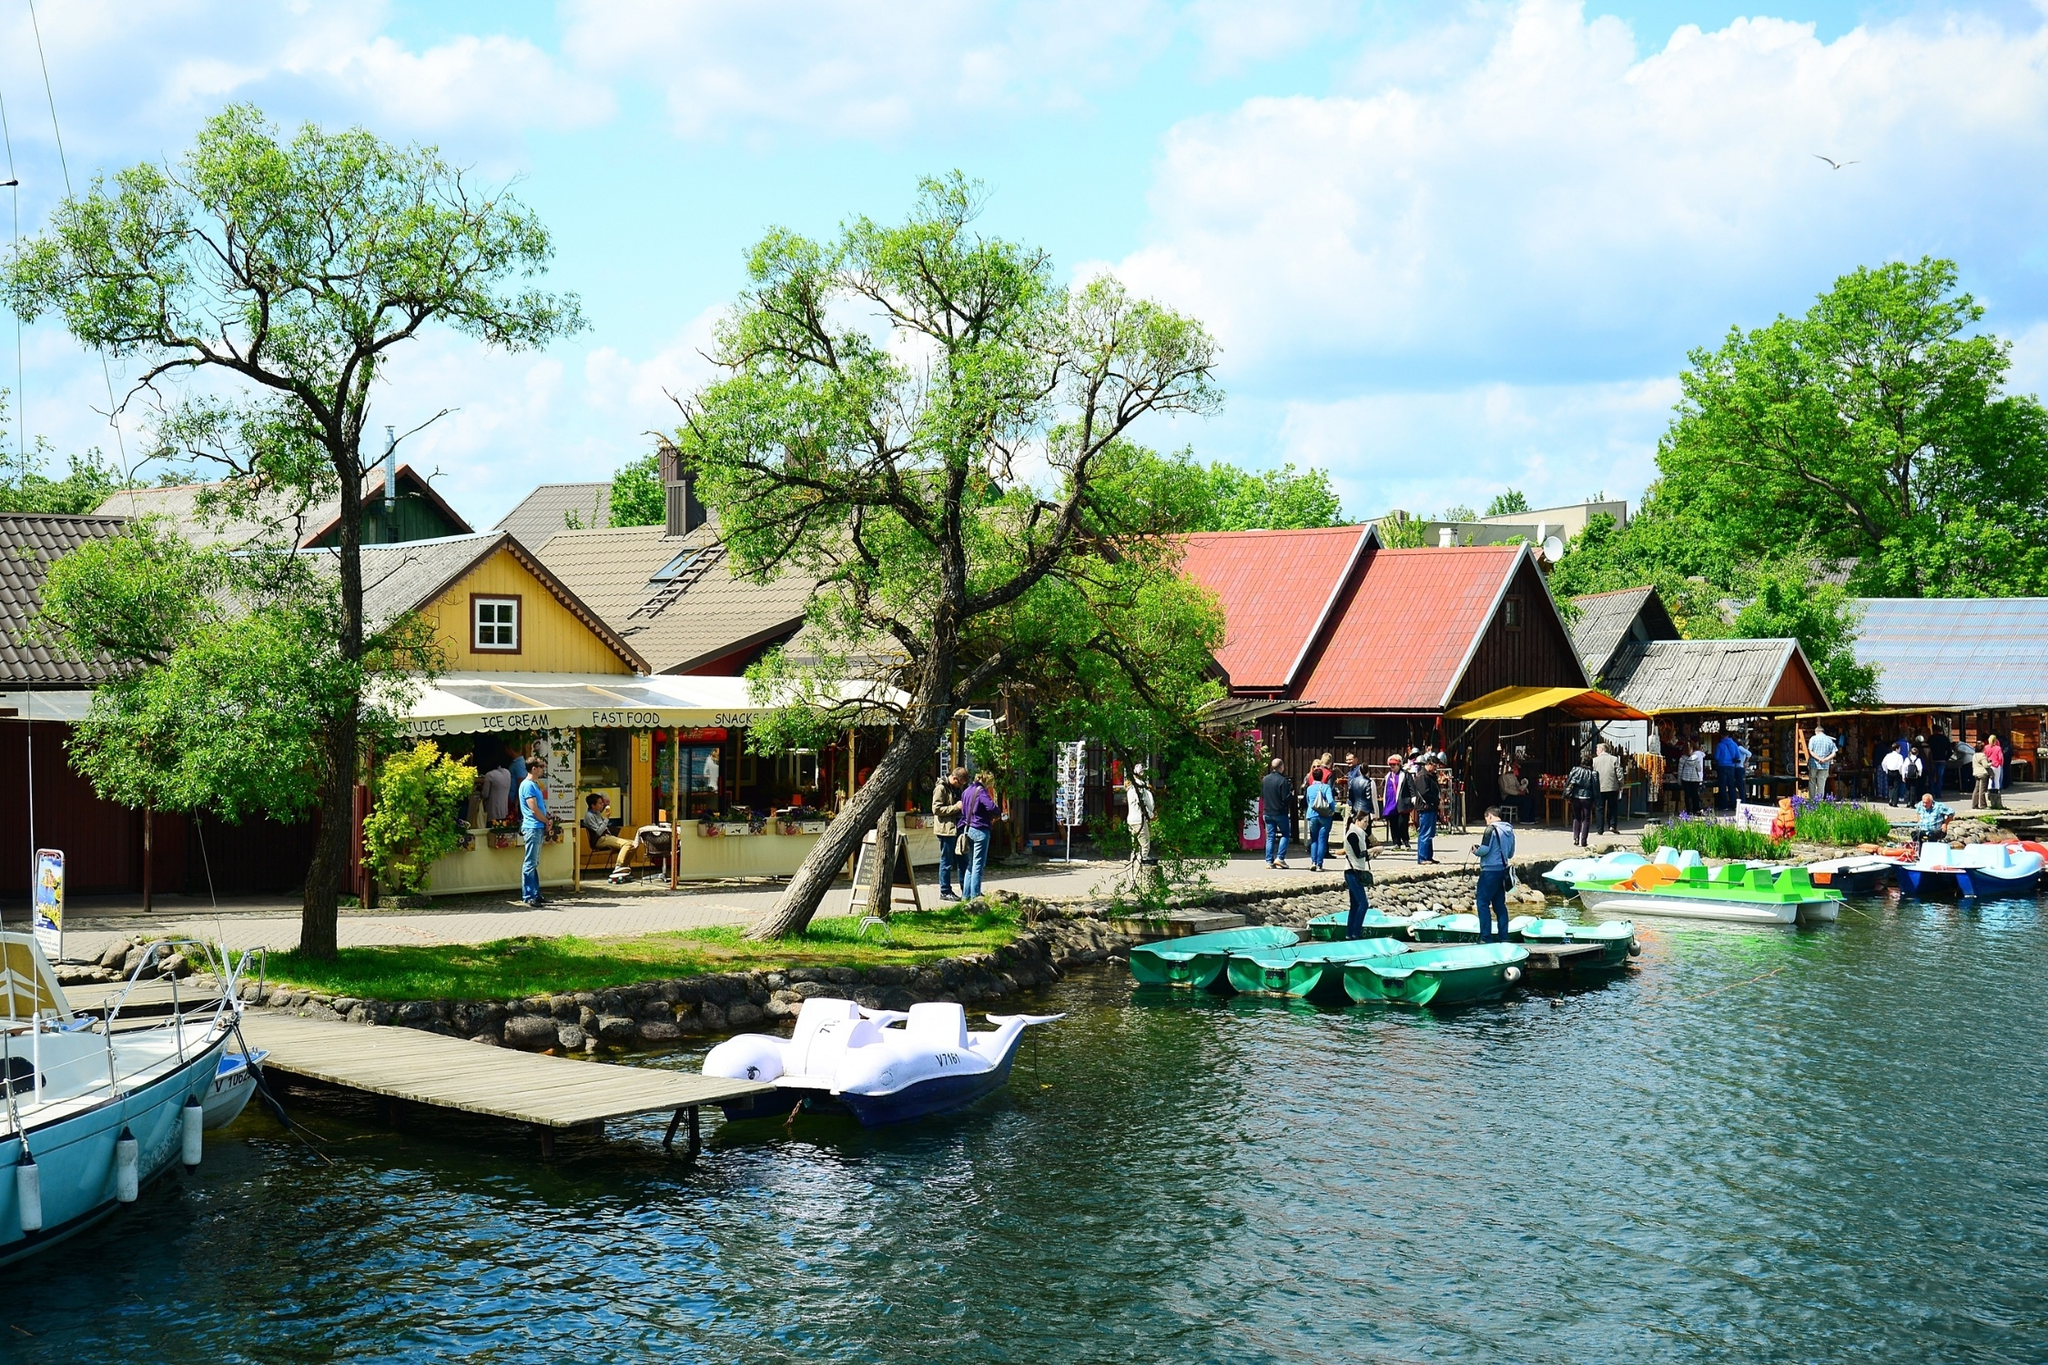Imagine this village is visited by a group of aliens. Describe their interaction with the villagers. When a group of curious and friendly aliens visited the village by the lake, the scene was nothing short of extraordinary. Their spaceship, a sleek and luminous craft, landed gently on the lake, causing ripples that glittered like stars. The villagers, initially startled, gathered around cautiously but with growing excitement and curiosity. The aliens, humanoid in appearance but with glowing skin and gentle, melodic voices, emerged from their craft and began to communicate with the villagers through a series of harmonic sounds and symbols. The villagers, intrigued, reciprocated with gestures of welcome, offering the aliens snacks from the kiosk. The aliens, fascinated by the earthly flavors, expressed their delight through mesmerizing light patterns emanating from their bodies. As the day went on, the villagers and aliens shared stories, learning about each other's worlds and technologies. The encounter fostered a bond of mutual respect and wonder, leaving both the villagers and the aliens enriched by this unique cultural exchange. 